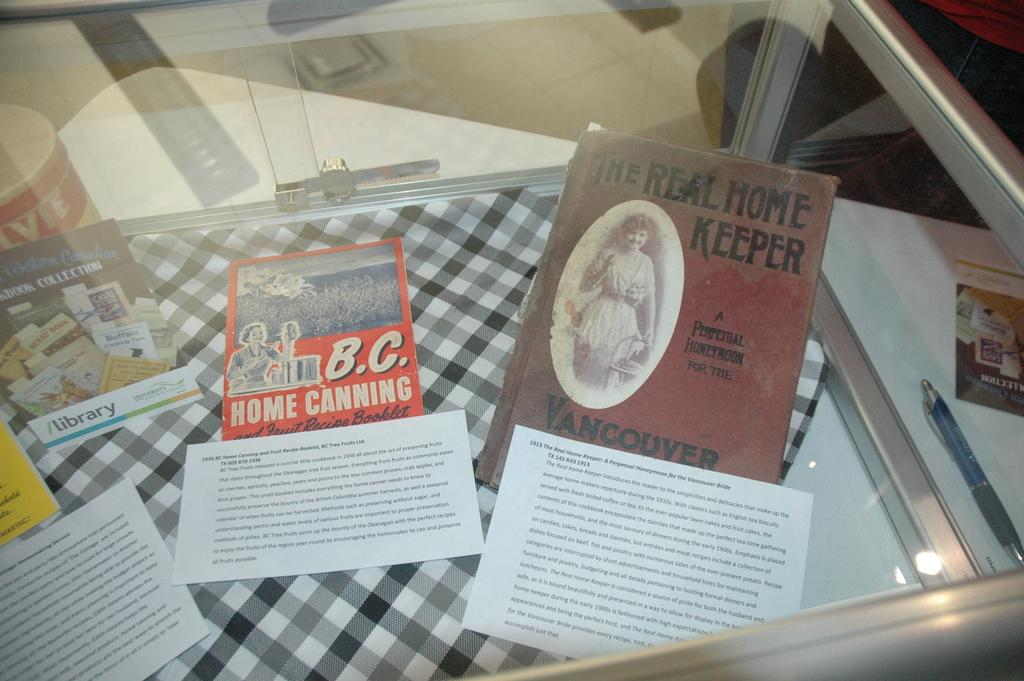Provide a one-sentence caption for the provided image. Several books on display like Home Canning and The Real Home Keeper. 